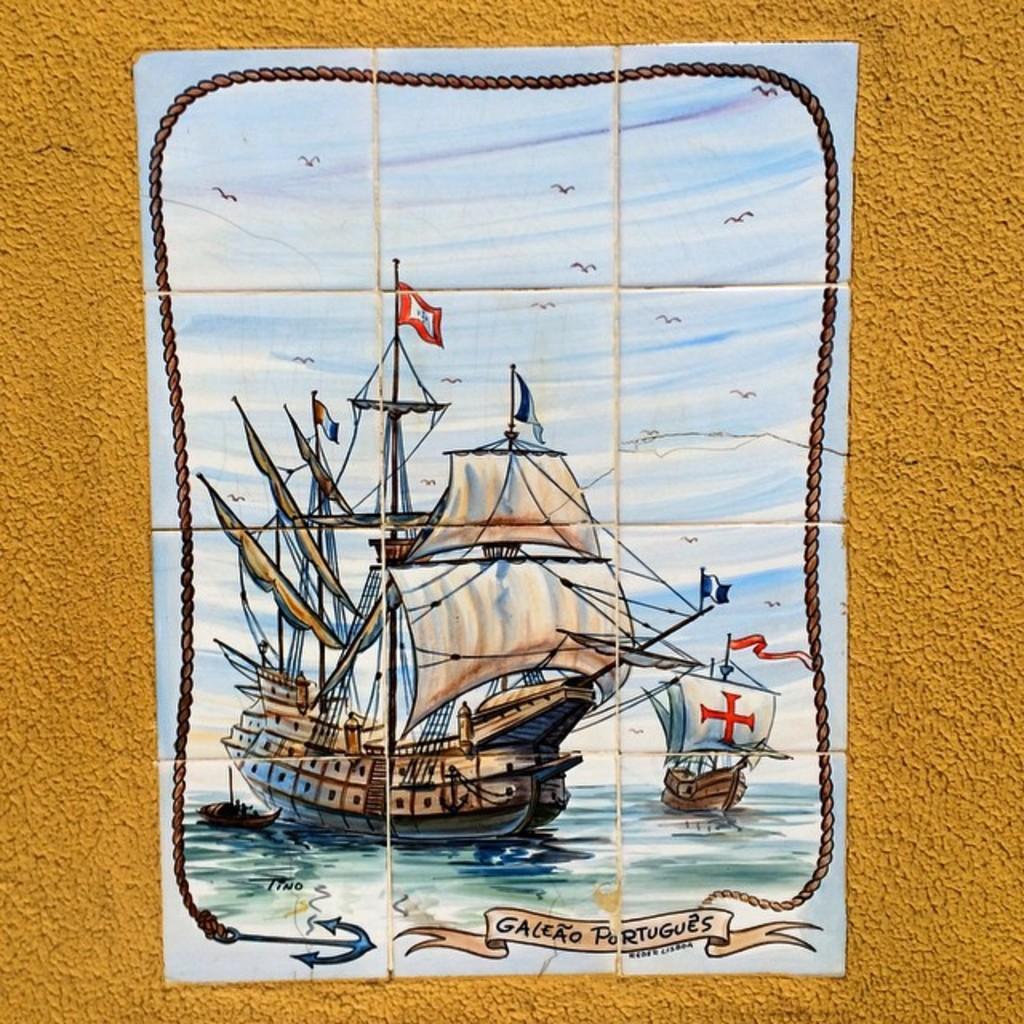Could you give a brief overview of what you see in this image? In this picture there is a ship poster in the center of the image, which is placed on a wall. 